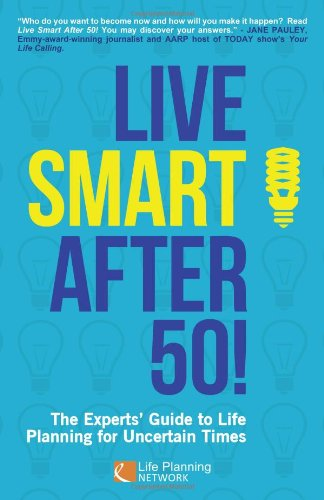Is this a motivational book? Yes, 'Live Smart After 50!' is indeed a motivational book, aimed at inspiring and guiding individuals navigating their life after fifty. 